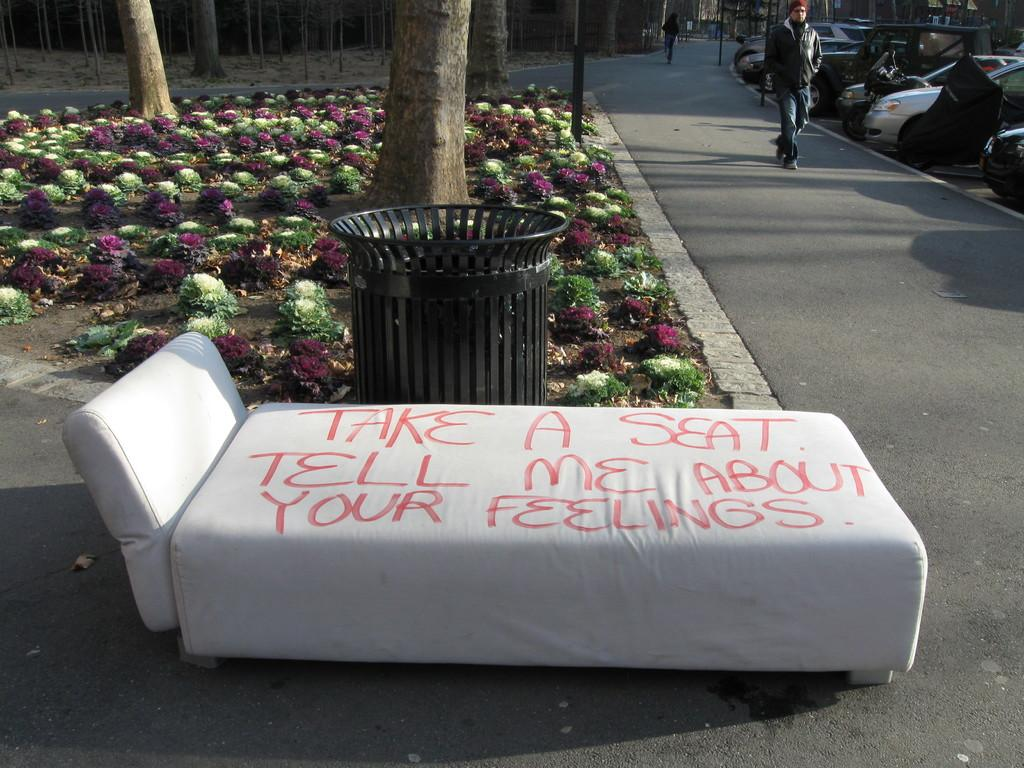What type of furniture is present in the image? There is a bed in the image. What is written on the bed? There is text written on the bed. What type of container is visible in the image? There is a bin in the image. Who or what can be seen in the image? There are people visible in the image. What can be seen in the background of the image? There are trees and cars in the background of the image. What type of vegetation is present in the image? There are shrubs in the image. What type of team is visible in the image? There is no team present in the image. What is the good-bye message written on the bed? There is no good-bye message written on the bed; there is just text, and its content is not specified in the facts. How many clams are visible in the image? There are no clams present in the image. 